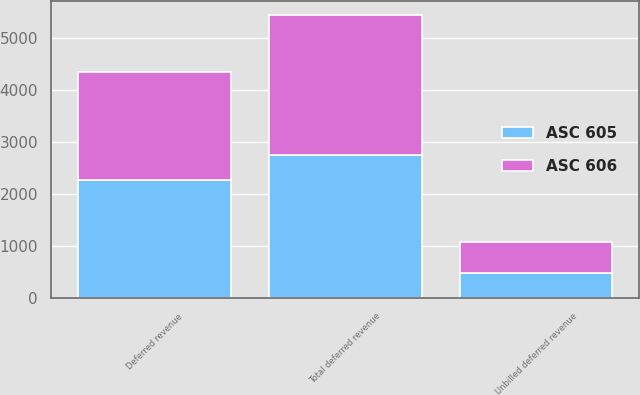Convert chart. <chart><loc_0><loc_0><loc_500><loc_500><stacked_bar_chart><ecel><fcel>Deferred revenue<fcel>Unbilled deferred revenue<fcel>Total deferred revenue<nl><fcel>ASC 606<fcel>2091.4<fcel>591<fcel>2682.4<nl><fcel>ASC 605<fcel>2269.2<fcel>491.6<fcel>2760.8<nl></chart> 